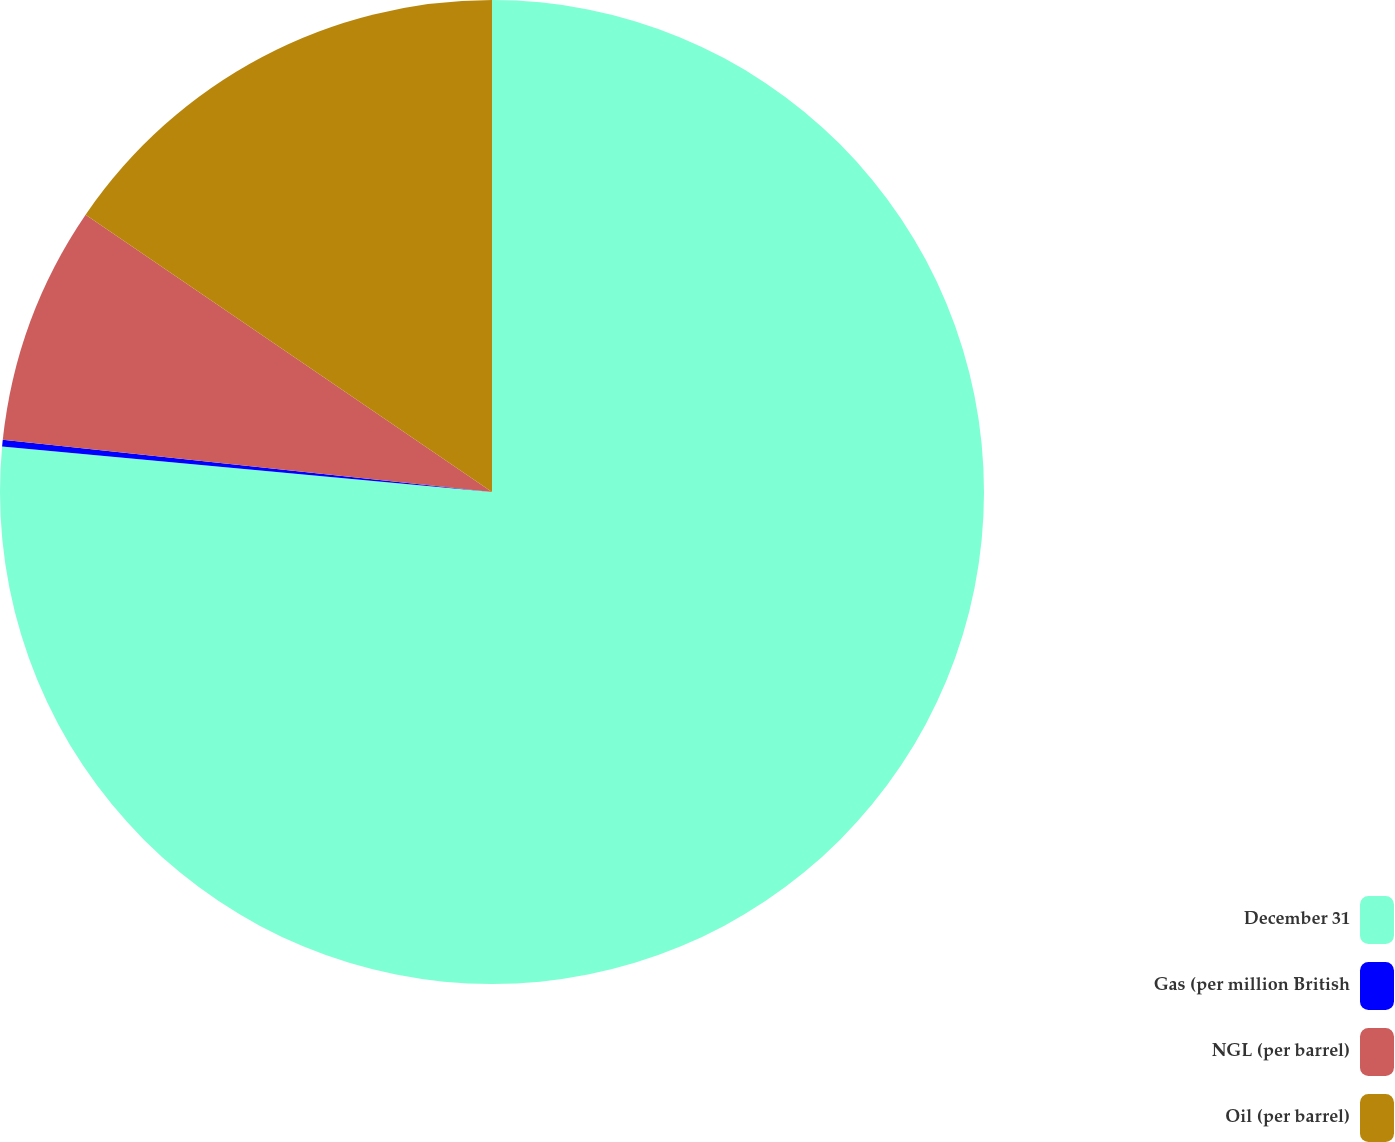Convert chart to OTSL. <chart><loc_0><loc_0><loc_500><loc_500><pie_chart><fcel>December 31<fcel>Gas (per million British<fcel>NGL (per barrel)<fcel>Oil (per barrel)<nl><fcel>76.47%<fcel>0.22%<fcel>7.84%<fcel>15.47%<nl></chart> 